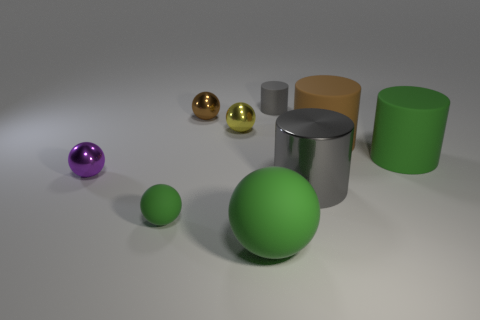Subtract all large green balls. How many balls are left? 4 Subtract all green cylinders. How many cylinders are left? 3 Subtract 0 blue blocks. How many objects are left? 9 Subtract all spheres. How many objects are left? 4 Subtract 2 balls. How many balls are left? 3 Subtract all gray spheres. Subtract all gray cylinders. How many spheres are left? 5 Subtract all cyan spheres. How many brown cylinders are left? 1 Subtract all brown cylinders. Subtract all large gray cylinders. How many objects are left? 7 Add 7 big green matte spheres. How many big green matte spheres are left? 8 Add 5 blue objects. How many blue objects exist? 5 